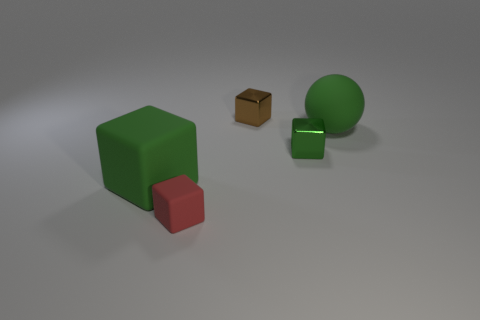What is the shape of the object that is on the right side of the large rubber cube and in front of the small green metal cube?
Give a very brief answer. Cube. There is a big green object that is right of the small rubber thing; is its shape the same as the red thing?
Provide a short and direct response. No. Do the tiny red thing and the tiny green metal thing have the same shape?
Your response must be concise. Yes. What is the shape of the big green rubber thing in front of the large green rubber thing that is behind the tiny green metal cube?
Make the answer very short. Cube. What is the color of the big thing that is right of the green metal object?
Make the answer very short. Green. What is the size of the green block that is made of the same material as the small brown object?
Your answer should be very brief. Small. There is a red thing that is the same shape as the brown object; what size is it?
Your answer should be compact. Small. Are there any tiny green metallic things?
Your answer should be compact. Yes. How many things are things behind the red block or large yellow matte spheres?
Provide a short and direct response. 4. What is the material of the red thing that is the same size as the brown block?
Your response must be concise. Rubber. 